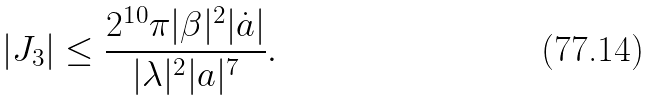Convert formula to latex. <formula><loc_0><loc_0><loc_500><loc_500>| J _ { 3 } | \leq \frac { 2 ^ { 1 0 } \pi | \beta | ^ { 2 } | \dot { a } | } { | \lambda | ^ { 2 } | a | ^ { 7 } } .</formula> 